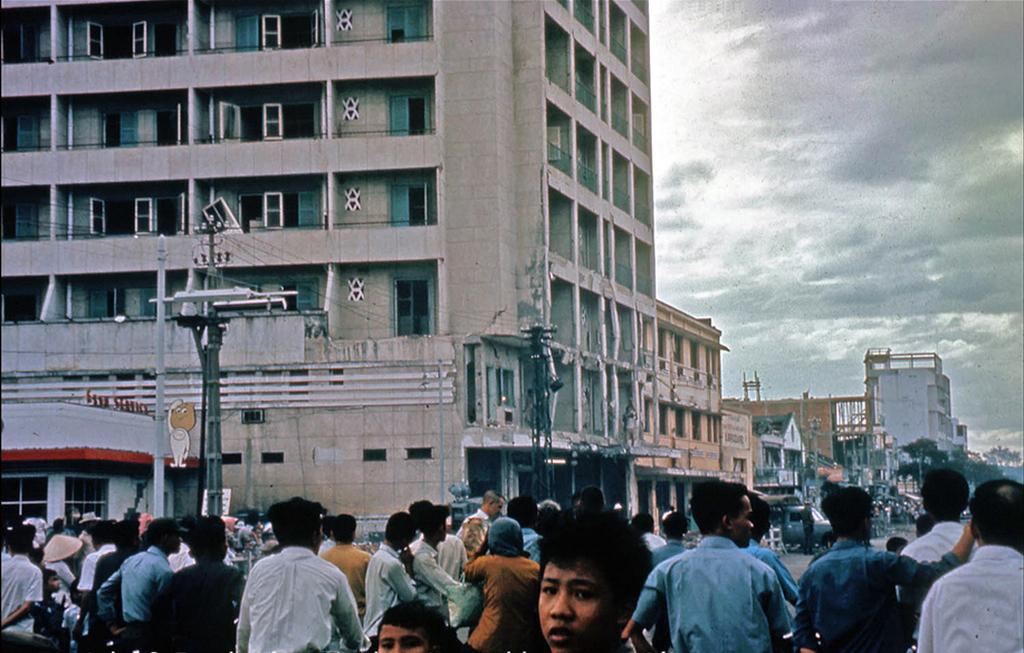How many people are in the group visible in the image? There is a group of people in the image, but the exact number cannot be determined from the provided facts. What type of vehicle is on the ground in the image? The facts do not specify the type of vehicle on the ground. What are the poles used for in the image? The purpose of the poles in the image cannot be determined from the provided facts. What can be seen inside the buildings with windows in the image? The facts do not provide information about what can be seen inside the buildings with windows. What is the weather like in the image? The sky with clouds visible in the background suggests that it is not a clear day, but the exact weather cannot be determined from the provided facts. Can you see the mother of the group in the image? There is no mention of a mother or any specific individuals in the group in the provided facts, so it cannot be determined if a mother is present in the image. Is there any fog visible in the image? The facts do not mention fog, and the presence of clouds in the sky does not necessarily indicate fog. Are there any sails visible in the image? There is no mention of sails or any maritime elements in the provided facts. 